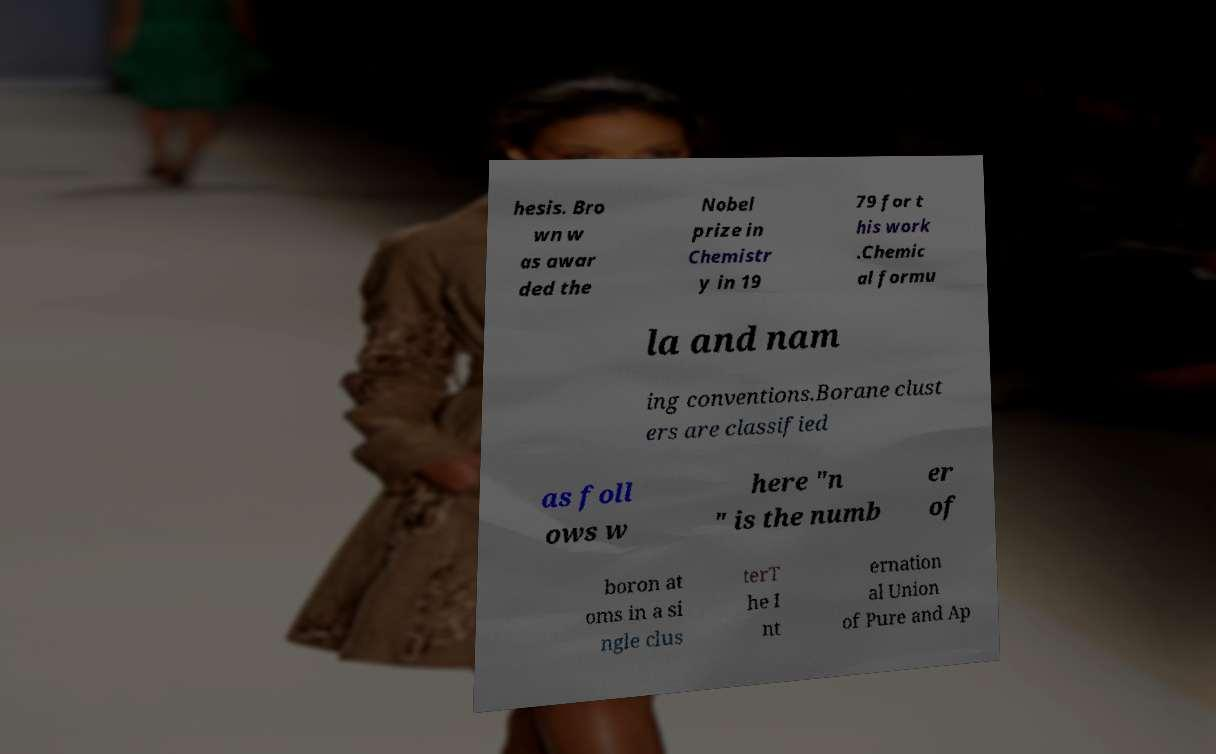Please identify and transcribe the text found in this image. hesis. Bro wn w as awar ded the Nobel prize in Chemistr y in 19 79 for t his work .Chemic al formu la and nam ing conventions.Borane clust ers are classified as foll ows w here "n " is the numb er of boron at oms in a si ngle clus terT he I nt ernation al Union of Pure and Ap 